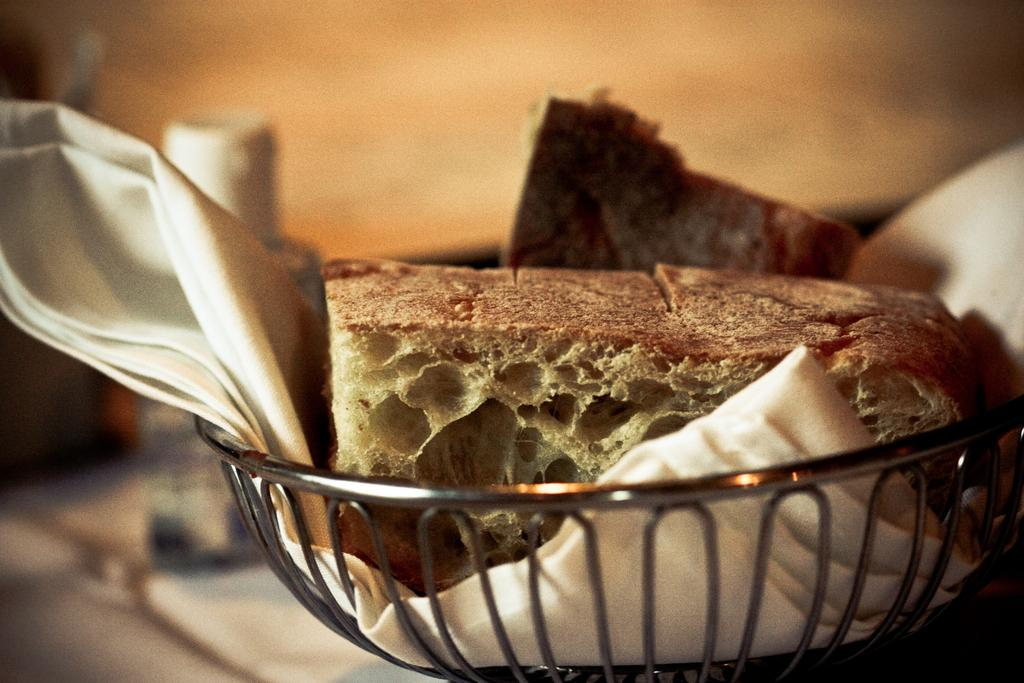What is in the bowl that is visible in the image? There is a bowl with food in the image. What else can be seen in the image besides the bowl of food? There is a cloth in the image. Is the bread in the image hot? There is no bread present in the image, so it cannot be determined if it is hot or not. 